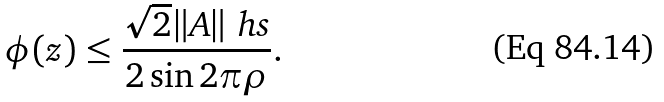<formula> <loc_0><loc_0><loc_500><loc_500>\phi ( z ) \leq \frac { \sqrt { 2 } \| A \| _ { \ } h s } { 2 \sin 2 \pi \rho } .</formula> 